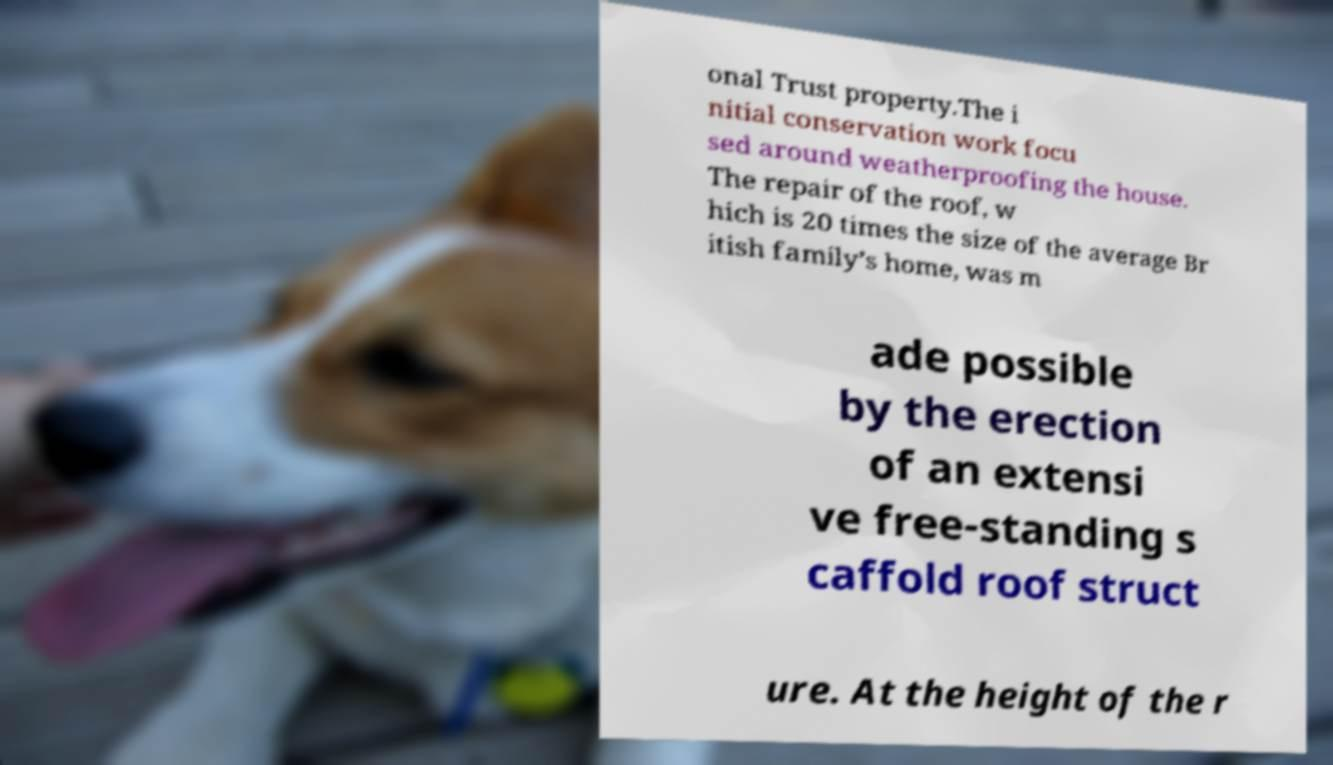Could you extract and type out the text from this image? onal Trust property.The i nitial conservation work focu sed around weatherproofing the house. The repair of the roof, w hich is 20 times the size of the average Br itish family’s home, was m ade possible by the erection of an extensi ve free-standing s caffold roof struct ure. At the height of the r 